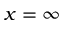Convert formula to latex. <formula><loc_0><loc_0><loc_500><loc_500>x = \infty</formula> 